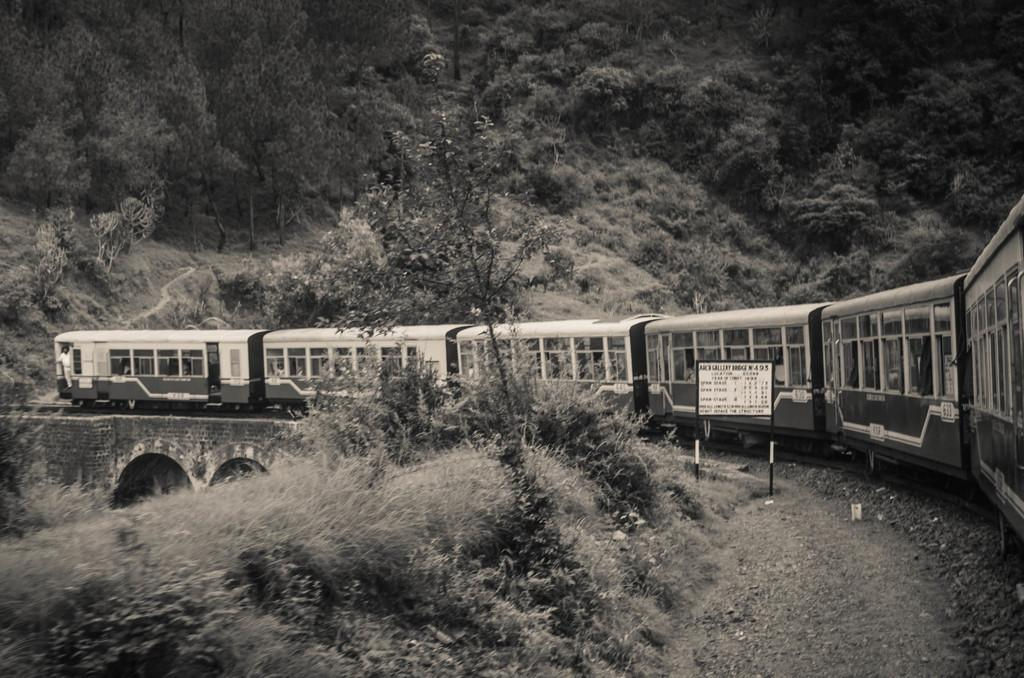What is the main subject of the image? The main subject of the image is a train. Where is the train located in the image? The train is on a track in the image. What else can be seen in the image besides the train? There is a board with text and trees in the image. Are there any other natural elements present in the image? Yes, there are plants in the image. What is the price of the yoke being sold at the market in the image? There is no market or yoke present in the image; it features a train on a track with a board and trees. 